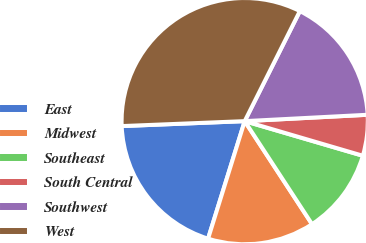Convert chart to OTSL. <chart><loc_0><loc_0><loc_500><loc_500><pie_chart><fcel>East<fcel>Midwest<fcel>Southeast<fcel>South Central<fcel>Southwest<fcel>West<nl><fcel>19.55%<fcel>14.02%<fcel>11.25%<fcel>5.36%<fcel>16.78%<fcel>33.03%<nl></chart> 